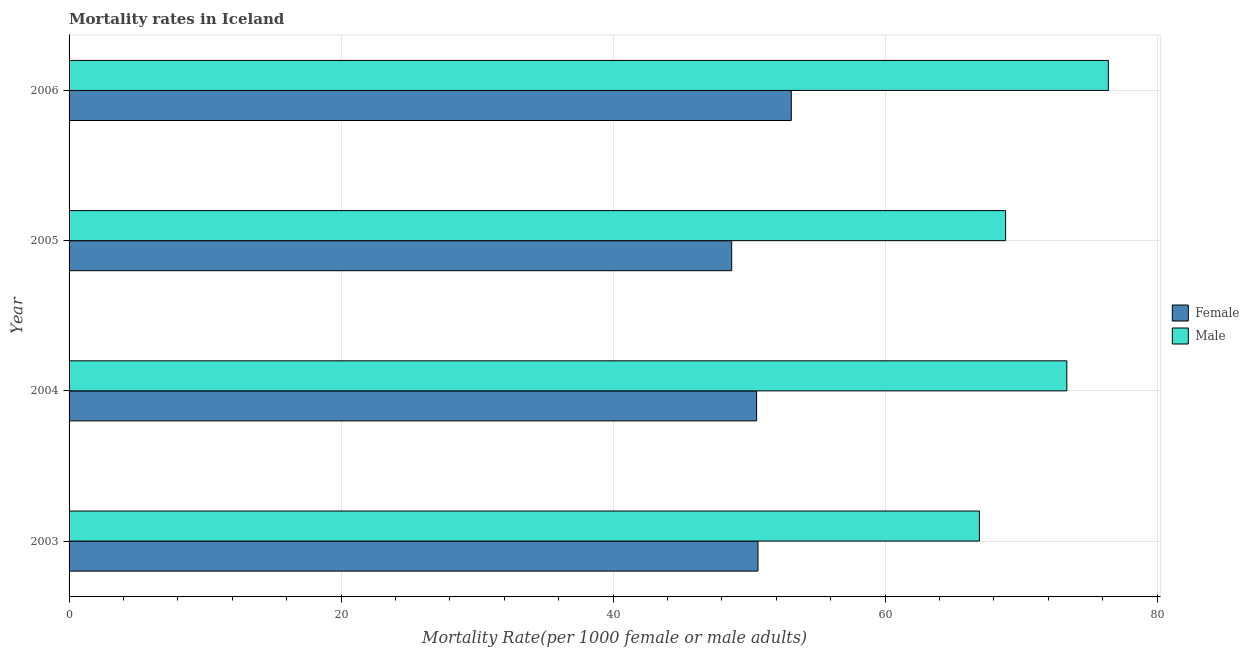How many groups of bars are there?
Ensure brevity in your answer.  4. How many bars are there on the 4th tick from the top?
Give a very brief answer. 2. How many bars are there on the 4th tick from the bottom?
Keep it short and to the point. 2. What is the label of the 1st group of bars from the top?
Give a very brief answer. 2006. What is the male mortality rate in 2005?
Make the answer very short. 68.86. Across all years, what is the maximum female mortality rate?
Ensure brevity in your answer.  53.1. Across all years, what is the minimum female mortality rate?
Your answer should be compact. 48.72. What is the total male mortality rate in the graph?
Provide a short and direct response. 285.58. What is the difference between the male mortality rate in 2004 and that in 2006?
Ensure brevity in your answer.  -3.05. What is the difference between the male mortality rate in 2006 and the female mortality rate in 2003?
Your answer should be compact. 25.76. What is the average female mortality rate per year?
Offer a terse response. 50.76. In the year 2005, what is the difference between the female mortality rate and male mortality rate?
Offer a very short reply. -20.14. In how many years, is the female mortality rate greater than 20 ?
Offer a very short reply. 4. What is the ratio of the male mortality rate in 2003 to that in 2006?
Keep it short and to the point. 0.88. Is the female mortality rate in 2003 less than that in 2006?
Your answer should be compact. Yes. Is the difference between the male mortality rate in 2004 and 2005 greater than the difference between the female mortality rate in 2004 and 2005?
Your answer should be compact. Yes. What is the difference between the highest and the second highest male mortality rate?
Your response must be concise. 3.05. What is the difference between the highest and the lowest male mortality rate?
Keep it short and to the point. 9.48. What does the 1st bar from the bottom in 2004 represents?
Give a very brief answer. Female. How many bars are there?
Your answer should be compact. 8. Are all the bars in the graph horizontal?
Make the answer very short. Yes. What is the difference between two consecutive major ticks on the X-axis?
Make the answer very short. 20. Are the values on the major ticks of X-axis written in scientific E-notation?
Your answer should be very brief. No. Does the graph contain grids?
Give a very brief answer. Yes. Where does the legend appear in the graph?
Your answer should be compact. Center right. What is the title of the graph?
Ensure brevity in your answer.  Mortality rates in Iceland. Does "Working only" appear as one of the legend labels in the graph?
Keep it short and to the point. No. What is the label or title of the X-axis?
Make the answer very short. Mortality Rate(per 1000 female or male adults). What is the label or title of the Y-axis?
Your answer should be very brief. Year. What is the Mortality Rate(per 1000 female or male adults) in Female in 2003?
Your answer should be very brief. 50.65. What is the Mortality Rate(per 1000 female or male adults) of Male in 2003?
Make the answer very short. 66.94. What is the Mortality Rate(per 1000 female or male adults) of Female in 2004?
Offer a very short reply. 50.55. What is the Mortality Rate(per 1000 female or male adults) of Male in 2004?
Make the answer very short. 73.37. What is the Mortality Rate(per 1000 female or male adults) of Female in 2005?
Your response must be concise. 48.72. What is the Mortality Rate(per 1000 female or male adults) in Male in 2005?
Ensure brevity in your answer.  68.86. What is the Mortality Rate(per 1000 female or male adults) of Female in 2006?
Give a very brief answer. 53.1. What is the Mortality Rate(per 1000 female or male adults) in Male in 2006?
Offer a terse response. 76.42. Across all years, what is the maximum Mortality Rate(per 1000 female or male adults) of Female?
Offer a very short reply. 53.1. Across all years, what is the maximum Mortality Rate(per 1000 female or male adults) in Male?
Keep it short and to the point. 76.42. Across all years, what is the minimum Mortality Rate(per 1000 female or male adults) of Female?
Keep it short and to the point. 48.72. Across all years, what is the minimum Mortality Rate(per 1000 female or male adults) in Male?
Offer a very short reply. 66.94. What is the total Mortality Rate(per 1000 female or male adults) of Female in the graph?
Provide a succinct answer. 203.03. What is the total Mortality Rate(per 1000 female or male adults) in Male in the graph?
Keep it short and to the point. 285.58. What is the difference between the Mortality Rate(per 1000 female or male adults) of Male in 2003 and that in 2004?
Provide a short and direct response. -6.43. What is the difference between the Mortality Rate(per 1000 female or male adults) in Female in 2003 and that in 2005?
Keep it short and to the point. 1.93. What is the difference between the Mortality Rate(per 1000 female or male adults) of Male in 2003 and that in 2005?
Offer a very short reply. -1.92. What is the difference between the Mortality Rate(per 1000 female or male adults) of Female in 2003 and that in 2006?
Your answer should be very brief. -2.45. What is the difference between the Mortality Rate(per 1000 female or male adults) in Male in 2003 and that in 2006?
Ensure brevity in your answer.  -9.48. What is the difference between the Mortality Rate(per 1000 female or male adults) in Female in 2004 and that in 2005?
Make the answer very short. 1.83. What is the difference between the Mortality Rate(per 1000 female or male adults) of Male in 2004 and that in 2005?
Ensure brevity in your answer.  4.5. What is the difference between the Mortality Rate(per 1000 female or male adults) in Female in 2004 and that in 2006?
Your response must be concise. -2.55. What is the difference between the Mortality Rate(per 1000 female or male adults) of Male in 2004 and that in 2006?
Make the answer very short. -3.05. What is the difference between the Mortality Rate(per 1000 female or male adults) of Female in 2005 and that in 2006?
Your answer should be compact. -4.38. What is the difference between the Mortality Rate(per 1000 female or male adults) of Male in 2005 and that in 2006?
Ensure brevity in your answer.  -7.56. What is the difference between the Mortality Rate(per 1000 female or male adults) of Female in 2003 and the Mortality Rate(per 1000 female or male adults) of Male in 2004?
Offer a terse response. -22.71. What is the difference between the Mortality Rate(per 1000 female or male adults) of Female in 2003 and the Mortality Rate(per 1000 female or male adults) of Male in 2005?
Make the answer very short. -18.21. What is the difference between the Mortality Rate(per 1000 female or male adults) in Female in 2003 and the Mortality Rate(per 1000 female or male adults) in Male in 2006?
Keep it short and to the point. -25.76. What is the difference between the Mortality Rate(per 1000 female or male adults) in Female in 2004 and the Mortality Rate(per 1000 female or male adults) in Male in 2005?
Give a very brief answer. -18.31. What is the difference between the Mortality Rate(per 1000 female or male adults) of Female in 2004 and the Mortality Rate(per 1000 female or male adults) of Male in 2006?
Make the answer very short. -25.86. What is the difference between the Mortality Rate(per 1000 female or male adults) of Female in 2005 and the Mortality Rate(per 1000 female or male adults) of Male in 2006?
Your answer should be very brief. -27.7. What is the average Mortality Rate(per 1000 female or male adults) in Female per year?
Provide a succinct answer. 50.76. What is the average Mortality Rate(per 1000 female or male adults) in Male per year?
Your answer should be very brief. 71.4. In the year 2003, what is the difference between the Mortality Rate(per 1000 female or male adults) in Female and Mortality Rate(per 1000 female or male adults) in Male?
Provide a short and direct response. -16.28. In the year 2004, what is the difference between the Mortality Rate(per 1000 female or male adults) in Female and Mortality Rate(per 1000 female or male adults) in Male?
Ensure brevity in your answer.  -22.81. In the year 2005, what is the difference between the Mortality Rate(per 1000 female or male adults) in Female and Mortality Rate(per 1000 female or male adults) in Male?
Keep it short and to the point. -20.14. In the year 2006, what is the difference between the Mortality Rate(per 1000 female or male adults) of Female and Mortality Rate(per 1000 female or male adults) of Male?
Keep it short and to the point. -23.31. What is the ratio of the Mortality Rate(per 1000 female or male adults) of Male in 2003 to that in 2004?
Your answer should be compact. 0.91. What is the ratio of the Mortality Rate(per 1000 female or male adults) of Female in 2003 to that in 2005?
Provide a succinct answer. 1.04. What is the ratio of the Mortality Rate(per 1000 female or male adults) of Male in 2003 to that in 2005?
Your response must be concise. 0.97. What is the ratio of the Mortality Rate(per 1000 female or male adults) of Female in 2003 to that in 2006?
Ensure brevity in your answer.  0.95. What is the ratio of the Mortality Rate(per 1000 female or male adults) of Male in 2003 to that in 2006?
Give a very brief answer. 0.88. What is the ratio of the Mortality Rate(per 1000 female or male adults) of Female in 2004 to that in 2005?
Give a very brief answer. 1.04. What is the ratio of the Mortality Rate(per 1000 female or male adults) in Male in 2004 to that in 2005?
Give a very brief answer. 1.07. What is the ratio of the Mortality Rate(per 1000 female or male adults) in Male in 2004 to that in 2006?
Your response must be concise. 0.96. What is the ratio of the Mortality Rate(per 1000 female or male adults) in Female in 2005 to that in 2006?
Offer a very short reply. 0.92. What is the ratio of the Mortality Rate(per 1000 female or male adults) in Male in 2005 to that in 2006?
Give a very brief answer. 0.9. What is the difference between the highest and the second highest Mortality Rate(per 1000 female or male adults) of Female?
Ensure brevity in your answer.  2.45. What is the difference between the highest and the second highest Mortality Rate(per 1000 female or male adults) in Male?
Your answer should be compact. 3.05. What is the difference between the highest and the lowest Mortality Rate(per 1000 female or male adults) of Female?
Provide a succinct answer. 4.38. What is the difference between the highest and the lowest Mortality Rate(per 1000 female or male adults) of Male?
Make the answer very short. 9.48. 